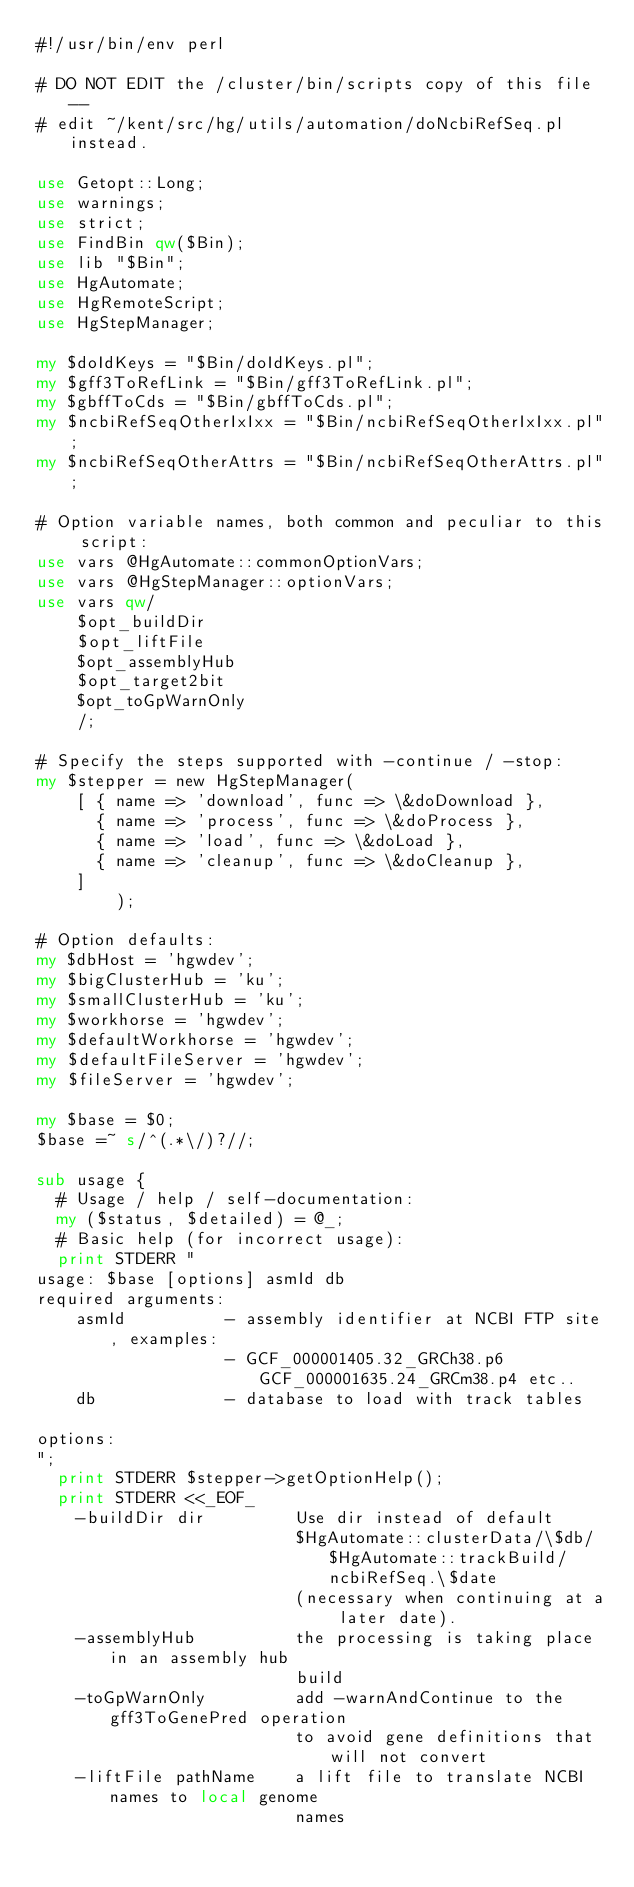Convert code to text. <code><loc_0><loc_0><loc_500><loc_500><_Perl_>#!/usr/bin/env perl

# DO NOT EDIT the /cluster/bin/scripts copy of this file --
# edit ~/kent/src/hg/utils/automation/doNcbiRefSeq.pl instead.

use Getopt::Long;
use warnings;
use strict;
use FindBin qw($Bin);
use lib "$Bin";
use HgAutomate;
use HgRemoteScript;
use HgStepManager;

my $doIdKeys = "$Bin/doIdKeys.pl";
my $gff3ToRefLink = "$Bin/gff3ToRefLink.pl";
my $gbffToCds = "$Bin/gbffToCds.pl";
my $ncbiRefSeqOtherIxIxx = "$Bin/ncbiRefSeqOtherIxIxx.pl";
my $ncbiRefSeqOtherAttrs = "$Bin/ncbiRefSeqOtherAttrs.pl";

# Option variable names, both common and peculiar to this script:
use vars @HgAutomate::commonOptionVars;
use vars @HgStepManager::optionVars;
use vars qw/
    $opt_buildDir
    $opt_liftFile
    $opt_assemblyHub
    $opt_target2bit
    $opt_toGpWarnOnly
    /;

# Specify the steps supported with -continue / -stop:
my $stepper = new HgStepManager(
    [ { name => 'download', func => \&doDownload },
      { name => 'process', func => \&doProcess },
      { name => 'load', func => \&doLoad },
      { name => 'cleanup', func => \&doCleanup },
    ]
				);

# Option defaults:
my $dbHost = 'hgwdev';
my $bigClusterHub = 'ku';
my $smallClusterHub = 'ku';
my $workhorse = 'hgwdev';
my $defaultWorkhorse = 'hgwdev';
my $defaultFileServer = 'hgwdev';
my $fileServer = 'hgwdev';

my $base = $0;
$base =~ s/^(.*\/)?//;

sub usage {
  # Usage / help / self-documentation:
  my ($status, $detailed) = @_;
  # Basic help (for incorrect usage):
  print STDERR "
usage: $base [options] asmId db
required arguments:
    asmId          - assembly identifier at NCBI FTP site, examples:
                   - GCF_000001405.32_GRCh38.p6 GCF_000001635.24_GRCm38.p4 etc..
    db             - database to load with track tables

options:
";
  print STDERR $stepper->getOptionHelp();
  print STDERR <<_EOF_
    -buildDir dir         Use dir instead of default
                          $HgAutomate::clusterData/\$db/$HgAutomate::trackBuild/ncbiRefSeq.\$date
                          (necessary when continuing at a later date).
    -assemblyHub          the processing is taking place in an assembly hub
                          build
    -toGpWarnOnly         add -warnAndContinue to the gff3ToGenePred operation
                          to avoid gene definitions that will not convert
    -liftFile pathName    a lift file to translate NCBI names to local genome
                          names</code> 